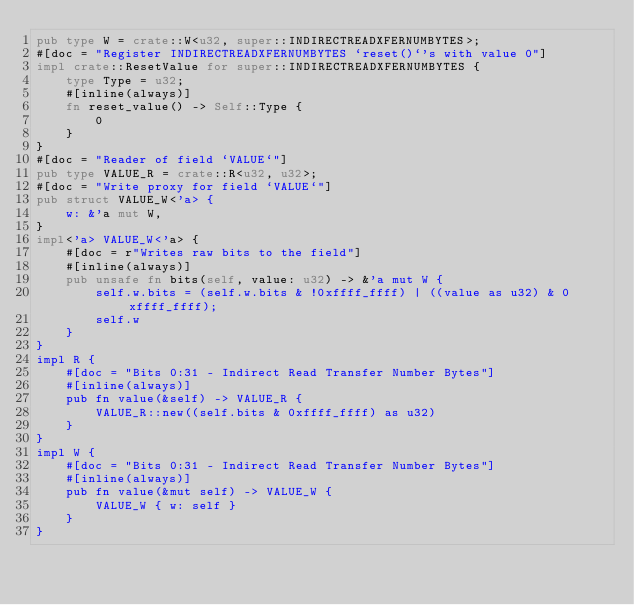<code> <loc_0><loc_0><loc_500><loc_500><_Rust_>pub type W = crate::W<u32, super::INDIRECTREADXFERNUMBYTES>;
#[doc = "Register INDIRECTREADXFERNUMBYTES `reset()`'s with value 0"]
impl crate::ResetValue for super::INDIRECTREADXFERNUMBYTES {
    type Type = u32;
    #[inline(always)]
    fn reset_value() -> Self::Type {
        0
    }
}
#[doc = "Reader of field `VALUE`"]
pub type VALUE_R = crate::R<u32, u32>;
#[doc = "Write proxy for field `VALUE`"]
pub struct VALUE_W<'a> {
    w: &'a mut W,
}
impl<'a> VALUE_W<'a> {
    #[doc = r"Writes raw bits to the field"]
    #[inline(always)]
    pub unsafe fn bits(self, value: u32) -> &'a mut W {
        self.w.bits = (self.w.bits & !0xffff_ffff) | ((value as u32) & 0xffff_ffff);
        self.w
    }
}
impl R {
    #[doc = "Bits 0:31 - Indirect Read Transfer Number Bytes"]
    #[inline(always)]
    pub fn value(&self) -> VALUE_R {
        VALUE_R::new((self.bits & 0xffff_ffff) as u32)
    }
}
impl W {
    #[doc = "Bits 0:31 - Indirect Read Transfer Number Bytes"]
    #[inline(always)]
    pub fn value(&mut self) -> VALUE_W {
        VALUE_W { w: self }
    }
}
</code> 